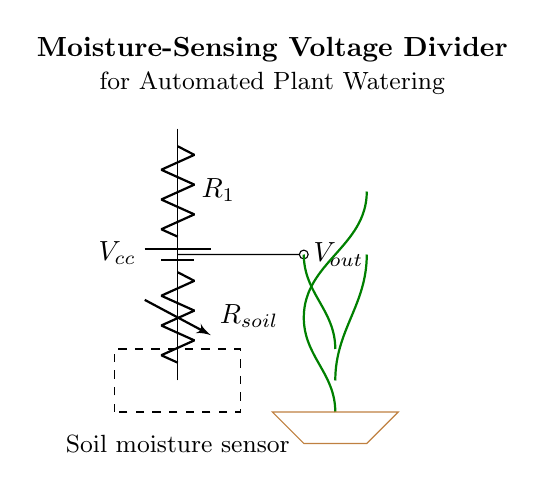What is the role of R1 in this circuit? R1 is a fixed resistor that, along with the variable resistor Rsoil, forms a voltage divider. It sets a portion of the total voltage to be measured.
Answer: Fixed resistor What does Vout represent? Vout represents the output voltage from the voltage divider, which is measured across the soil moisture sensor. It provides a value that indicates the soil moisture level.
Answer: Output voltage What type of sensor is used in this circuit? The circuit uses a soil moisture sensor, which detects the moisture content in the soil.
Answer: Soil moisture sensor How do Rsoil and R1 affect Vout? As Rsoil changes with varying soil moisture levels, it alters the voltage drop across it, thus affecting Vout. When soil moisture is high, Rsoil decreases, increasing Vout.
Answer: They change Vout based on moisture levels What is the configuration of this voltage divider? The voltage divider is a series configuration of two resistors (R1 and Rsoil) where the output voltage is taken from the junction of the two resistors.
Answer: Series configuration How does soil moisture affect the resistance of Rsoil? When the soil is moist, the resistance of Rsoil is lower due to higher conductivity, allowing more current to flow and raising Vout. Conversely, dry soil increases Rsoil's resistance, lowering Vout.
Answer: Lower resistance when moist 